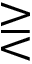Convert formula to latex. <formula><loc_0><loc_0><loc_500><loc_500>> r e q l e s s</formula> 